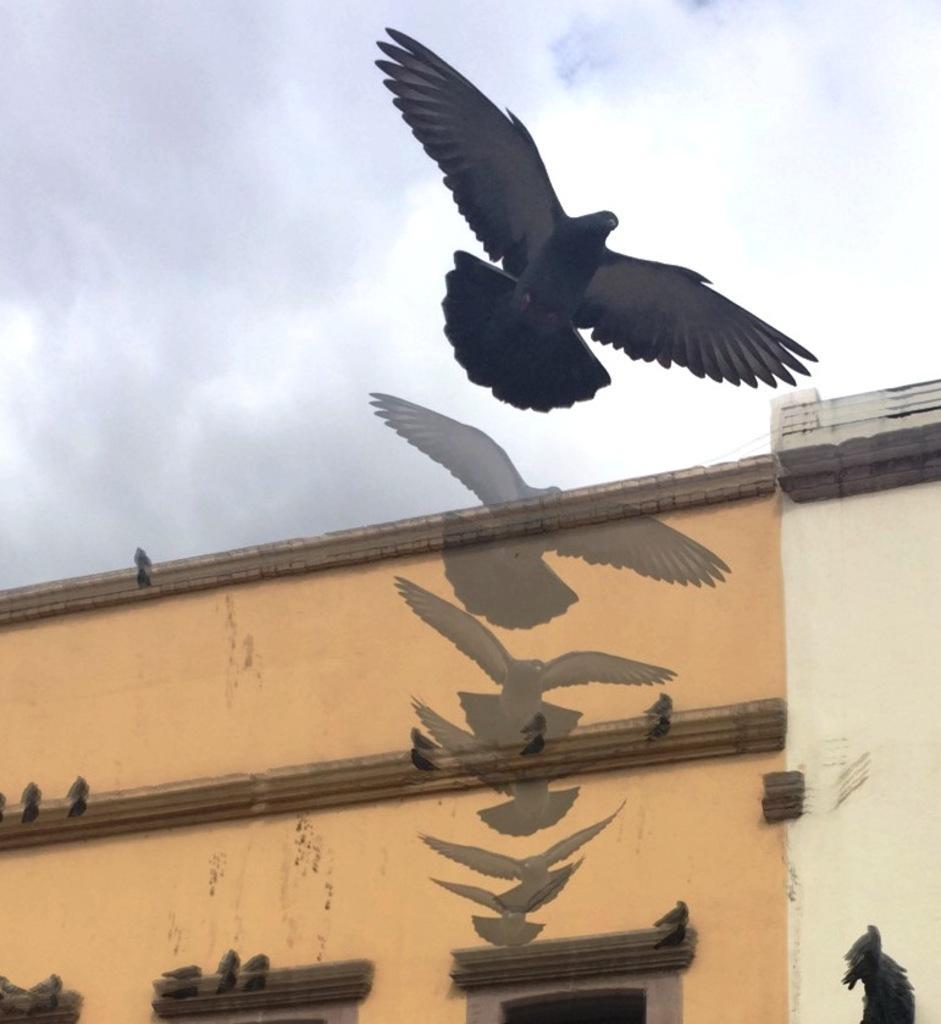How would you summarize this image in a sentence or two? In this image we can see a bird flying, there is a building, on the building we can see some birds and in the background we can see the sky with clouds. 